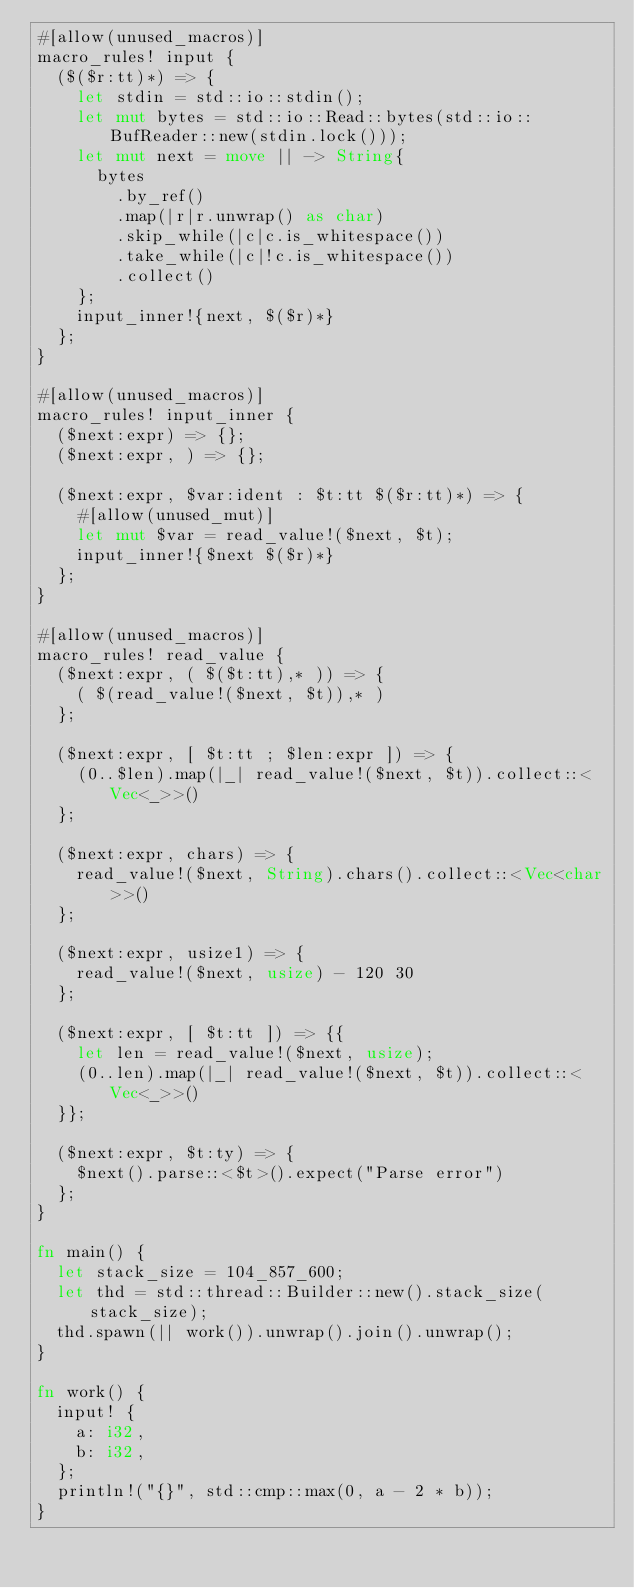Convert code to text. <code><loc_0><loc_0><loc_500><loc_500><_Rust_>#[allow(unused_macros)]
macro_rules! input {
  ($($r:tt)*) => {
    let stdin = std::io::stdin();
    let mut bytes = std::io::Read::bytes(std::io::BufReader::new(stdin.lock()));
    let mut next = move || -> String{
      bytes
        .by_ref()
        .map(|r|r.unwrap() as char)
        .skip_while(|c|c.is_whitespace())
        .take_while(|c|!c.is_whitespace())
        .collect()
    };
    input_inner!{next, $($r)*}
  };
}

#[allow(unused_macros)]
macro_rules! input_inner {
  ($next:expr) => {};
  ($next:expr, ) => {};

  ($next:expr, $var:ident : $t:tt $($r:tt)*) => {
    #[allow(unused_mut)]
    let mut $var = read_value!($next, $t);
    input_inner!{$next $($r)*}
  };
}

#[allow(unused_macros)]
macro_rules! read_value {
  ($next:expr, ( $($t:tt),* )) => {
    ( $(read_value!($next, $t)),* )
  };

  ($next:expr, [ $t:tt ; $len:expr ]) => {
    (0..$len).map(|_| read_value!($next, $t)).collect::<Vec<_>>()
  };

  ($next:expr, chars) => {
    read_value!($next, String).chars().collect::<Vec<char>>()
  };

  ($next:expr, usize1) => {
    read_value!($next, usize) - 120 30
  };

  ($next:expr, [ $t:tt ]) => {{
    let len = read_value!($next, usize);
    (0..len).map(|_| read_value!($next, $t)).collect::<Vec<_>>()
  }};

  ($next:expr, $t:ty) => {
    $next().parse::<$t>().expect("Parse error")
  };
}

fn main() {
  let stack_size = 104_857_600;
  let thd = std::thread::Builder::new().stack_size(stack_size);
  thd.spawn(|| work()).unwrap().join().unwrap();
}

fn work() {
  input! {
    a: i32,
    b: i32,
  };
  println!("{}", std::cmp::max(0, a - 2 * b));
}
</code> 